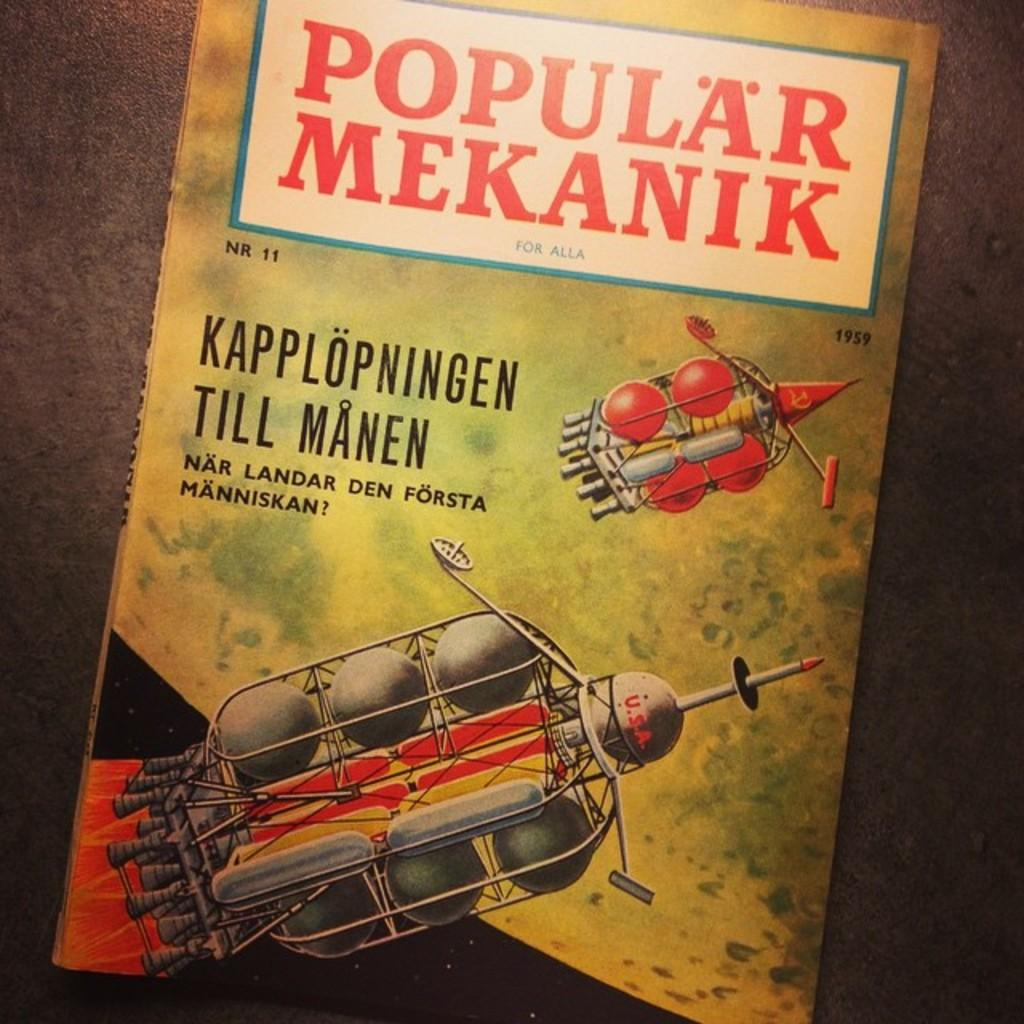What objects are present in the image? There are satellites and a book cover with text in the image. Can you describe the book cover in the image? The book cover has text on it. What might the text on the book cover be about? It is impossible to determine the content of the text from the image alone. How many men are pulling the satellites in the image? There are no men present in the image, and the satellites are not being pulled by any visible force. 